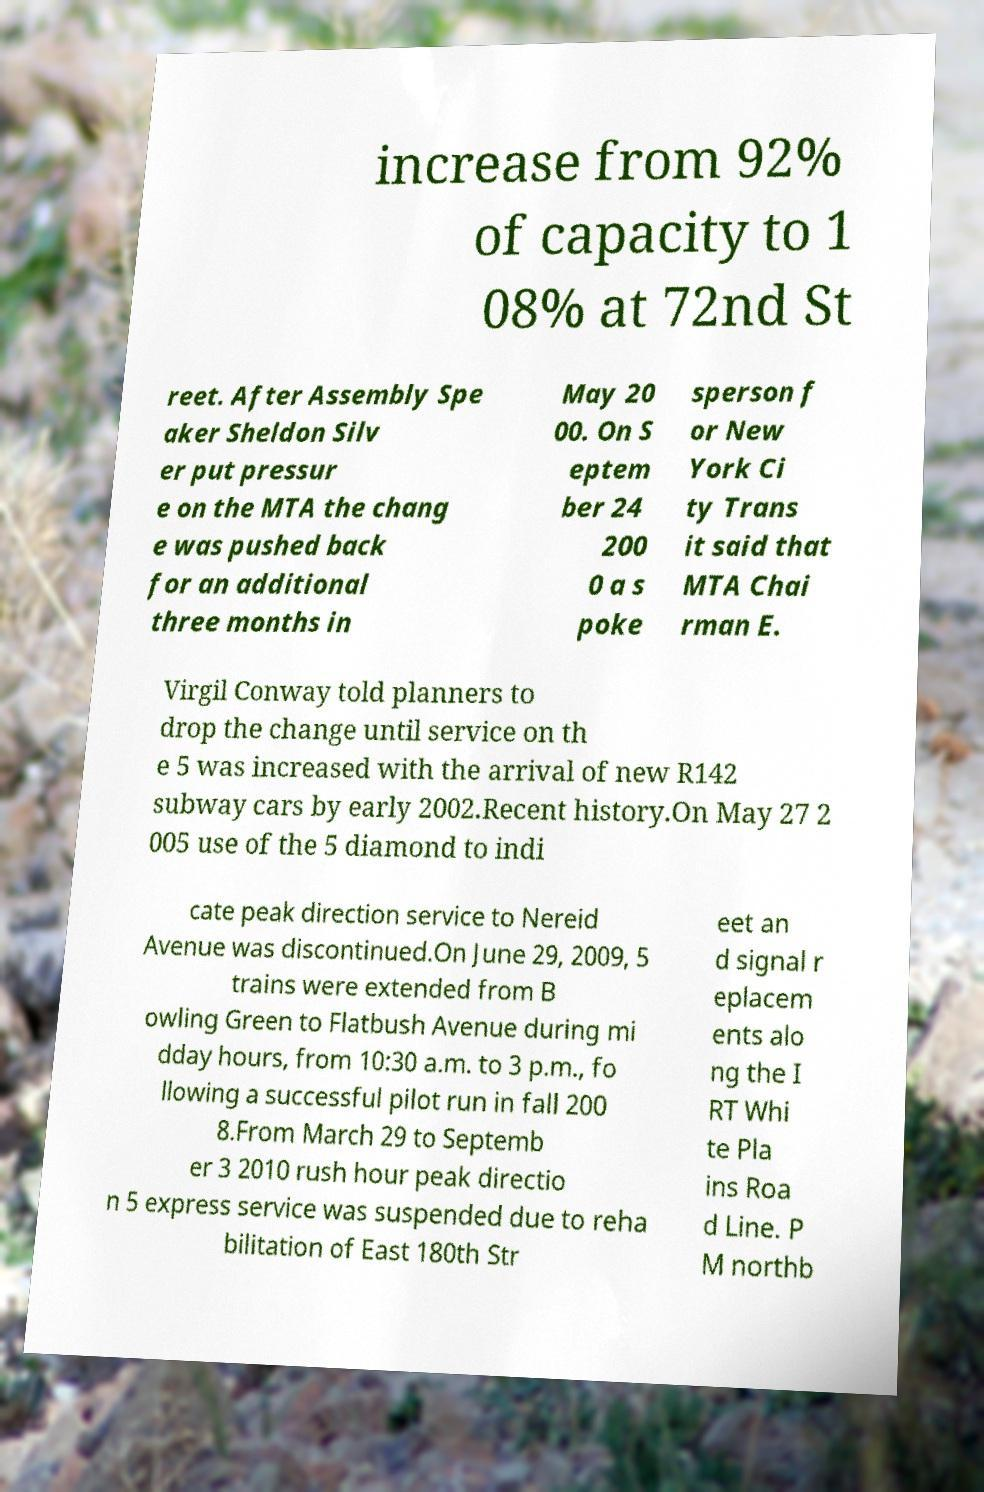I need the written content from this picture converted into text. Can you do that? increase from 92% of capacity to 1 08% at 72nd St reet. After Assembly Spe aker Sheldon Silv er put pressur e on the MTA the chang e was pushed back for an additional three months in May 20 00. On S eptem ber 24 200 0 a s poke sperson f or New York Ci ty Trans it said that MTA Chai rman E. Virgil Conway told planners to drop the change until service on th e 5 was increased with the arrival of new R142 subway cars by early 2002.Recent history.On May 27 2 005 use of the 5 diamond to indi cate peak direction service to Nereid Avenue was discontinued.On June 29, 2009, 5 trains were extended from B owling Green to Flatbush Avenue during mi dday hours, from 10:30 a.m. to 3 p.m., fo llowing a successful pilot run in fall 200 8.From March 29 to Septemb er 3 2010 rush hour peak directio n 5 express service was suspended due to reha bilitation of East 180th Str eet an d signal r eplacem ents alo ng the I RT Whi te Pla ins Roa d Line. P M northb 